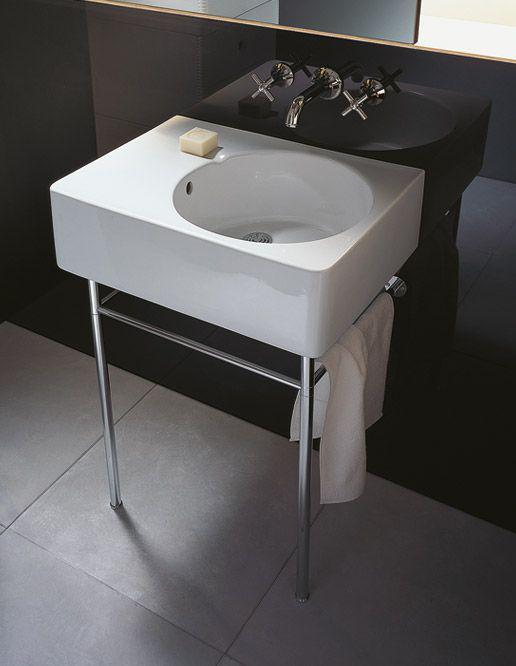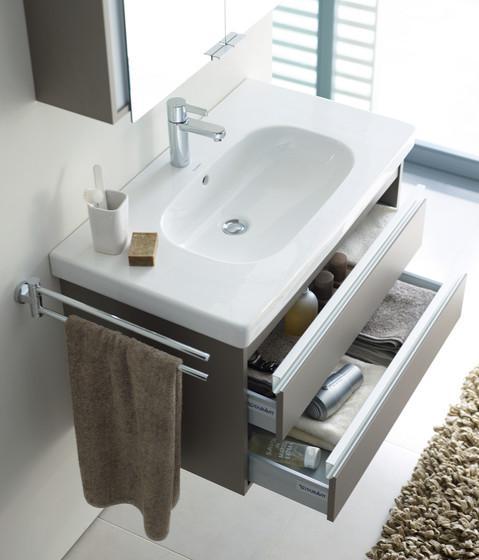The first image is the image on the left, the second image is the image on the right. Evaluate the accuracy of this statement regarding the images: "One of the sinks is inset in a rectangle above metal legs.". Is it true? Answer yes or no. Yes. 